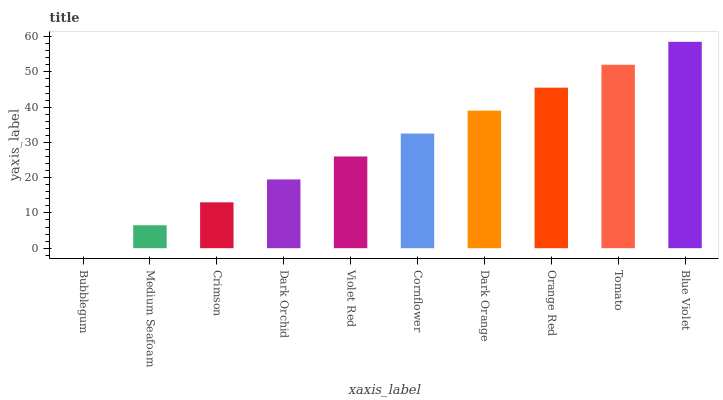Is Bubblegum the minimum?
Answer yes or no. Yes. Is Blue Violet the maximum?
Answer yes or no. Yes. Is Medium Seafoam the minimum?
Answer yes or no. No. Is Medium Seafoam the maximum?
Answer yes or no. No. Is Medium Seafoam greater than Bubblegum?
Answer yes or no. Yes. Is Bubblegum less than Medium Seafoam?
Answer yes or no. Yes. Is Bubblegum greater than Medium Seafoam?
Answer yes or no. No. Is Medium Seafoam less than Bubblegum?
Answer yes or no. No. Is Cornflower the high median?
Answer yes or no. Yes. Is Violet Red the low median?
Answer yes or no. Yes. Is Crimson the high median?
Answer yes or no. No. Is Tomato the low median?
Answer yes or no. No. 